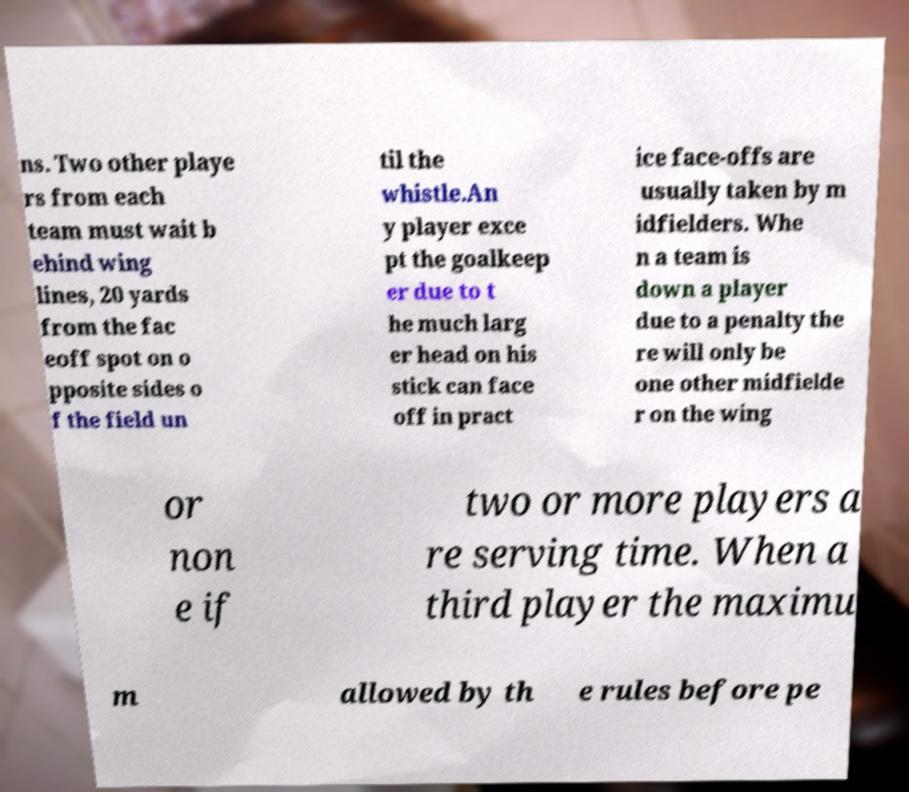Please read and relay the text visible in this image. What does it say? ns. Two other playe rs from each team must wait b ehind wing lines, 20 yards from the fac eoff spot on o pposite sides o f the field un til the whistle.An y player exce pt the goalkeep er due to t he much larg er head on his stick can face off in pract ice face-offs are usually taken by m idfielders. Whe n a team is down a player due to a penalty the re will only be one other midfielde r on the wing or non e if two or more players a re serving time. When a third player the maximu m allowed by th e rules before pe 